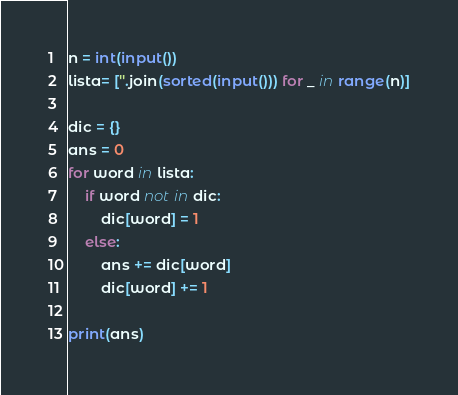<code> <loc_0><loc_0><loc_500><loc_500><_Python_>
n = int(input())
lista= [''.join(sorted(input())) for _ in range(n)]
 
dic = {}
ans = 0
for word in lista:
    if word not in dic:
        dic[word] = 1
    else:
        ans += dic[word]
        dic[word] += 1
 
print(ans)
</code> 